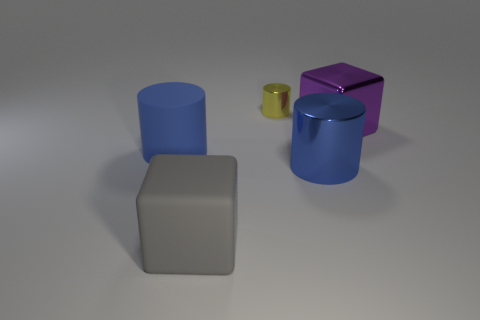Subtract all rubber cylinders. How many cylinders are left? 2 Subtract all purple cubes. How many blue cylinders are left? 2 Subtract all yellow cylinders. How many cylinders are left? 2 Add 5 large blue things. How many objects exist? 10 Subtract all blocks. How many objects are left? 3 Subtract 1 blocks. How many blocks are left? 1 Add 5 cylinders. How many cylinders are left? 8 Add 2 large brown metallic cylinders. How many large brown metallic cylinders exist? 2 Subtract 1 yellow cylinders. How many objects are left? 4 Subtract all brown blocks. Subtract all red cylinders. How many blocks are left? 2 